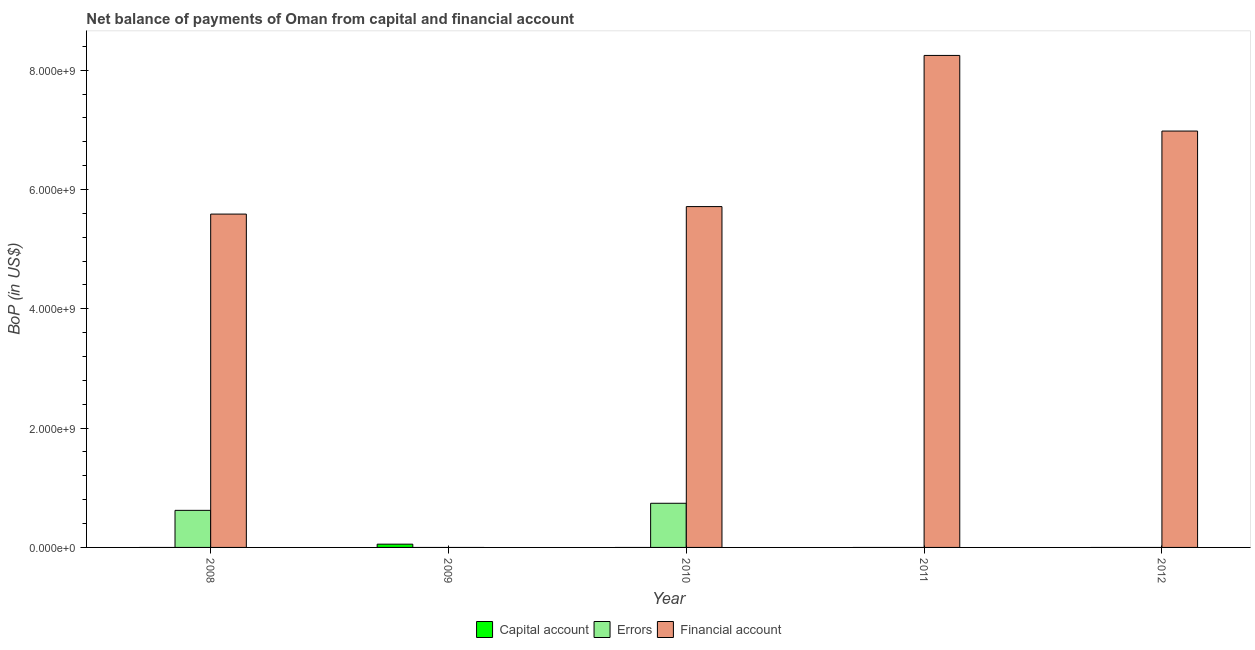What is the label of the 4th group of bars from the left?
Keep it short and to the point. 2011. In how many cases, is the number of bars for a given year not equal to the number of legend labels?
Make the answer very short. 5. What is the amount of errors in 2012?
Give a very brief answer. 0. Across all years, what is the maximum amount of errors?
Your response must be concise. 7.40e+08. Across all years, what is the minimum amount of financial account?
Offer a very short reply. 0. What is the total amount of errors in the graph?
Your answer should be compact. 1.36e+09. What is the difference between the amount of financial account in 2008 and that in 2011?
Offer a terse response. -2.66e+09. What is the difference between the amount of financial account in 2010 and the amount of errors in 2008?
Give a very brief answer. 1.26e+08. What is the average amount of net capital account per year?
Your response must be concise. 1.09e+07. In the year 2011, what is the difference between the amount of financial account and amount of net capital account?
Your answer should be compact. 0. What is the ratio of the amount of financial account in 2011 to that in 2012?
Offer a terse response. 1.18. What is the difference between the highest and the second highest amount of financial account?
Your answer should be compact. 1.27e+09. What is the difference between the highest and the lowest amount of net capital account?
Make the answer very short. 5.46e+07. Are all the bars in the graph horizontal?
Provide a short and direct response. No. How many years are there in the graph?
Keep it short and to the point. 5. Does the graph contain grids?
Your answer should be compact. No. What is the title of the graph?
Provide a succinct answer. Net balance of payments of Oman from capital and financial account. What is the label or title of the X-axis?
Ensure brevity in your answer.  Year. What is the label or title of the Y-axis?
Make the answer very short. BoP (in US$). What is the BoP (in US$) of Errors in 2008?
Provide a short and direct response. 6.22e+08. What is the BoP (in US$) of Financial account in 2008?
Your answer should be very brief. 5.59e+09. What is the BoP (in US$) in Capital account in 2009?
Give a very brief answer. 5.46e+07. What is the BoP (in US$) of Errors in 2009?
Offer a terse response. 0. What is the BoP (in US$) of Financial account in 2009?
Provide a short and direct response. 0. What is the BoP (in US$) in Capital account in 2010?
Offer a very short reply. 0. What is the BoP (in US$) in Errors in 2010?
Provide a short and direct response. 7.40e+08. What is the BoP (in US$) in Financial account in 2010?
Ensure brevity in your answer.  5.71e+09. What is the BoP (in US$) of Capital account in 2011?
Keep it short and to the point. 0. What is the BoP (in US$) in Errors in 2011?
Provide a short and direct response. 0. What is the BoP (in US$) in Financial account in 2011?
Your answer should be very brief. 8.25e+09. What is the BoP (in US$) of Errors in 2012?
Offer a terse response. 0. What is the BoP (in US$) of Financial account in 2012?
Keep it short and to the point. 6.98e+09. Across all years, what is the maximum BoP (in US$) of Capital account?
Your answer should be compact. 5.46e+07. Across all years, what is the maximum BoP (in US$) of Errors?
Keep it short and to the point. 7.40e+08. Across all years, what is the maximum BoP (in US$) of Financial account?
Your answer should be very brief. 8.25e+09. Across all years, what is the minimum BoP (in US$) of Capital account?
Offer a terse response. 0. Across all years, what is the minimum BoP (in US$) in Financial account?
Your response must be concise. 0. What is the total BoP (in US$) in Capital account in the graph?
Your response must be concise. 5.46e+07. What is the total BoP (in US$) of Errors in the graph?
Give a very brief answer. 1.36e+09. What is the total BoP (in US$) of Financial account in the graph?
Ensure brevity in your answer.  2.65e+1. What is the difference between the BoP (in US$) of Errors in 2008 and that in 2010?
Offer a terse response. -1.18e+08. What is the difference between the BoP (in US$) in Financial account in 2008 and that in 2010?
Your response must be concise. -1.26e+08. What is the difference between the BoP (in US$) in Financial account in 2008 and that in 2011?
Your answer should be compact. -2.66e+09. What is the difference between the BoP (in US$) of Financial account in 2008 and that in 2012?
Your answer should be compact. -1.39e+09. What is the difference between the BoP (in US$) of Financial account in 2010 and that in 2011?
Offer a very short reply. -2.53e+09. What is the difference between the BoP (in US$) in Financial account in 2010 and that in 2012?
Give a very brief answer. -1.27e+09. What is the difference between the BoP (in US$) of Financial account in 2011 and that in 2012?
Offer a terse response. 1.27e+09. What is the difference between the BoP (in US$) in Errors in 2008 and the BoP (in US$) in Financial account in 2010?
Your answer should be very brief. -5.09e+09. What is the difference between the BoP (in US$) in Errors in 2008 and the BoP (in US$) in Financial account in 2011?
Your response must be concise. -7.63e+09. What is the difference between the BoP (in US$) of Errors in 2008 and the BoP (in US$) of Financial account in 2012?
Provide a succinct answer. -6.36e+09. What is the difference between the BoP (in US$) in Capital account in 2009 and the BoP (in US$) in Errors in 2010?
Offer a very short reply. -6.85e+08. What is the difference between the BoP (in US$) of Capital account in 2009 and the BoP (in US$) of Financial account in 2010?
Provide a succinct answer. -5.66e+09. What is the difference between the BoP (in US$) in Capital account in 2009 and the BoP (in US$) in Financial account in 2011?
Your response must be concise. -8.19e+09. What is the difference between the BoP (in US$) of Capital account in 2009 and the BoP (in US$) of Financial account in 2012?
Your answer should be very brief. -6.93e+09. What is the difference between the BoP (in US$) in Errors in 2010 and the BoP (in US$) in Financial account in 2011?
Your answer should be very brief. -7.51e+09. What is the difference between the BoP (in US$) of Errors in 2010 and the BoP (in US$) of Financial account in 2012?
Provide a succinct answer. -6.24e+09. What is the average BoP (in US$) in Capital account per year?
Ensure brevity in your answer.  1.09e+07. What is the average BoP (in US$) of Errors per year?
Your answer should be very brief. 2.72e+08. What is the average BoP (in US$) in Financial account per year?
Offer a terse response. 5.31e+09. In the year 2008, what is the difference between the BoP (in US$) in Errors and BoP (in US$) in Financial account?
Your answer should be compact. -4.97e+09. In the year 2010, what is the difference between the BoP (in US$) of Errors and BoP (in US$) of Financial account?
Your answer should be compact. -4.97e+09. What is the ratio of the BoP (in US$) in Errors in 2008 to that in 2010?
Ensure brevity in your answer.  0.84. What is the ratio of the BoP (in US$) in Financial account in 2008 to that in 2011?
Your answer should be compact. 0.68. What is the ratio of the BoP (in US$) of Financial account in 2008 to that in 2012?
Ensure brevity in your answer.  0.8. What is the ratio of the BoP (in US$) in Financial account in 2010 to that in 2011?
Your response must be concise. 0.69. What is the ratio of the BoP (in US$) in Financial account in 2010 to that in 2012?
Keep it short and to the point. 0.82. What is the ratio of the BoP (in US$) of Financial account in 2011 to that in 2012?
Your response must be concise. 1.18. What is the difference between the highest and the second highest BoP (in US$) in Financial account?
Provide a short and direct response. 1.27e+09. What is the difference between the highest and the lowest BoP (in US$) of Capital account?
Offer a terse response. 5.46e+07. What is the difference between the highest and the lowest BoP (in US$) in Errors?
Ensure brevity in your answer.  7.40e+08. What is the difference between the highest and the lowest BoP (in US$) in Financial account?
Ensure brevity in your answer.  8.25e+09. 